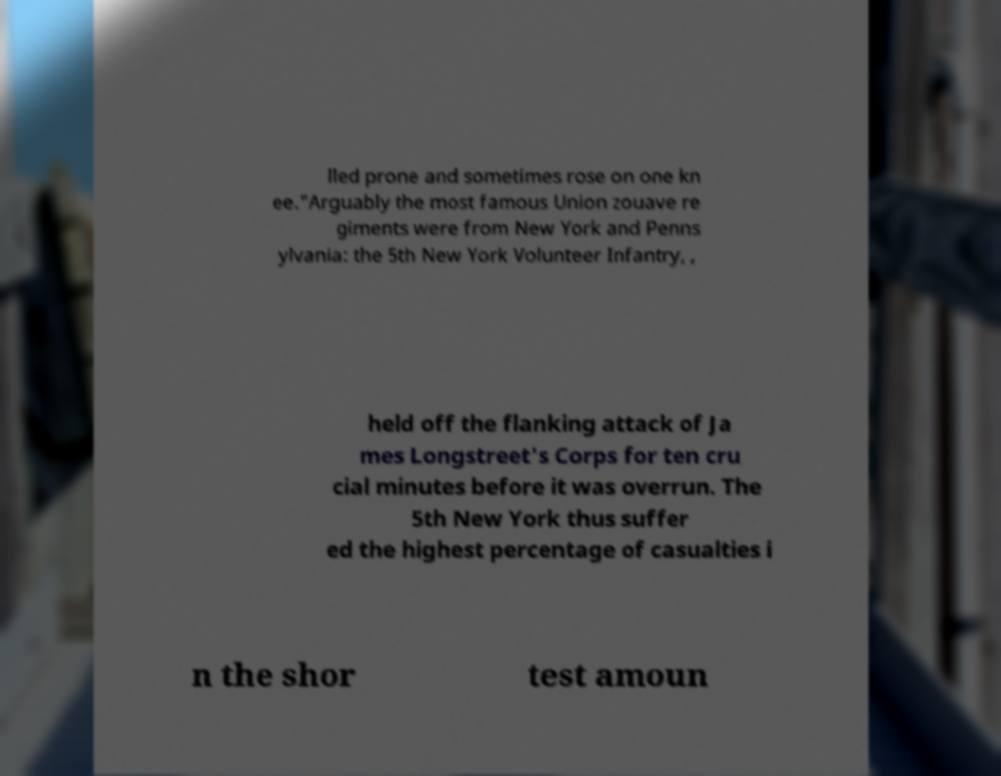Can you read and provide the text displayed in the image?This photo seems to have some interesting text. Can you extract and type it out for me? lled prone and sometimes rose on one kn ee."Arguably the most famous Union zouave re giments were from New York and Penns ylvania: the 5th New York Volunteer Infantry, , held off the flanking attack of Ja mes Longstreet's Corps for ten cru cial minutes before it was overrun. The 5th New York thus suffer ed the highest percentage of casualties i n the shor test amoun 